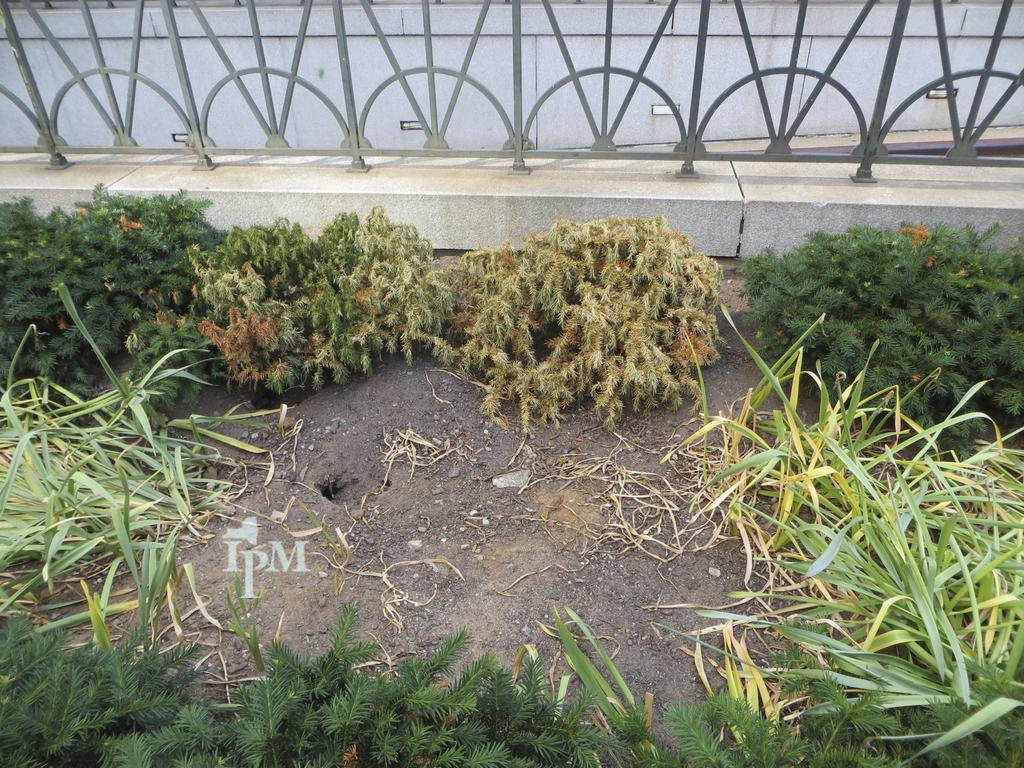What structure can be seen in the image? There is a bridge in the image. What feature is present on the top of the bridge? The bridge has hand grills on the top. What type of vegetation is located near the bridge? There are plants beside the bridge. What type of ground cover is visible at the bottom of the image? There is grass at the bottom of the image. Are there any other plants visible in the image? Yes, there are plants at the bottom of the image. What time of day is it in the image, and how does the bucket contribute to the scene? The time of day is not mentioned in the image, and there is no bucket present in the image. 